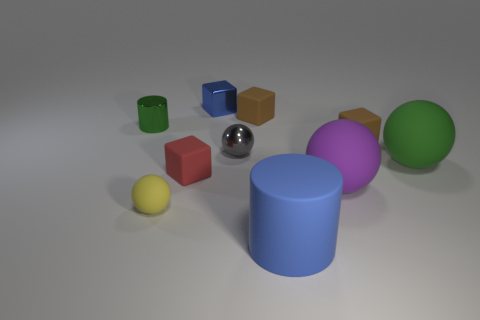Subtract all blue metal blocks. How many blocks are left? 3 Subtract 1 cylinders. How many cylinders are left? 1 Subtract all balls. How many objects are left? 6 Subtract all yellow balls. How many balls are left? 3 Subtract all purple spheres. How many blue cubes are left? 1 Subtract all blue shiny cubes. Subtract all large rubber spheres. How many objects are left? 7 Add 9 small green metallic things. How many small green metallic things are left? 10 Add 1 yellow metal things. How many yellow metal things exist? 1 Subtract 0 cyan blocks. How many objects are left? 10 Subtract all brown cylinders. Subtract all brown spheres. How many cylinders are left? 2 